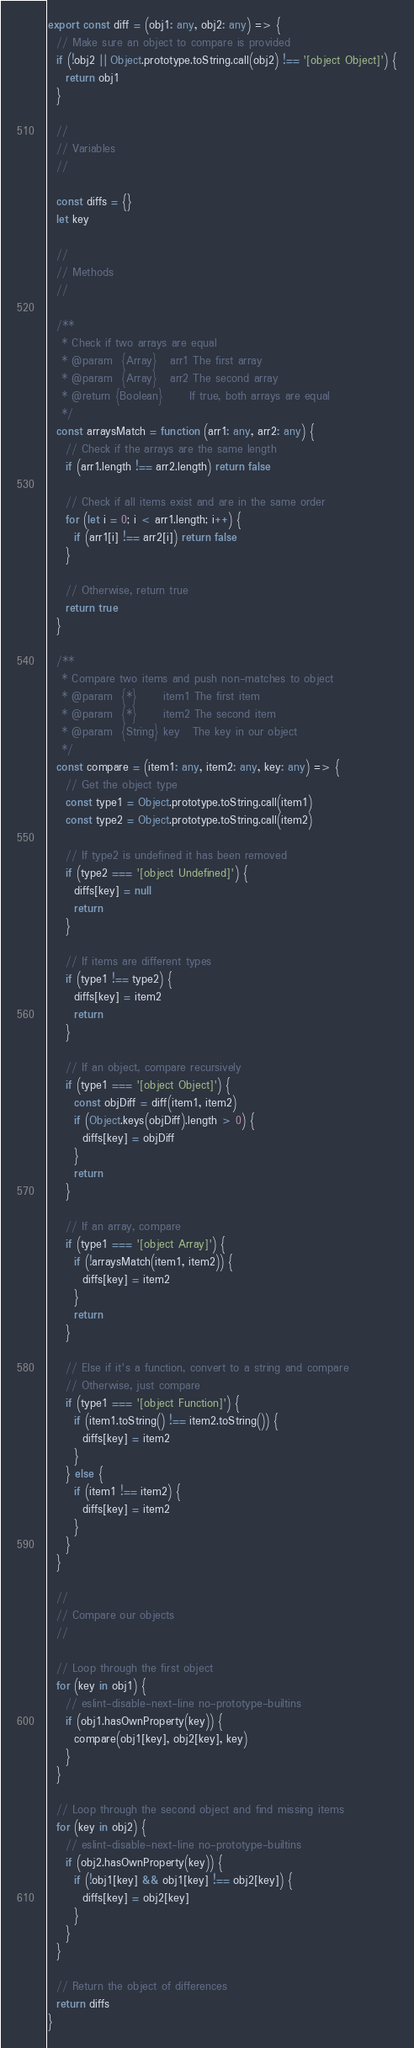<code> <loc_0><loc_0><loc_500><loc_500><_TypeScript_>export const diff = (obj1: any, obj2: any) => {
  // Make sure an object to compare is provided
  if (!obj2 || Object.prototype.toString.call(obj2) !== '[object Object]') {
    return obj1
  }

  //
  // Variables
  //

  const diffs = {}
  let key

  //
  // Methods
  //

  /**
   * Check if two arrays are equal
   * @param  {Array}   arr1 The first array
   * @param  {Array}   arr2 The second array
   * @return {Boolean}      If true, both arrays are equal
   */
  const arraysMatch = function (arr1: any, arr2: any) {
    // Check if the arrays are the same length
    if (arr1.length !== arr2.length) return false

    // Check if all items exist and are in the same order
    for (let i = 0; i < arr1.length; i++) {
      if (arr1[i] !== arr2[i]) return false
    }

    // Otherwise, return true
    return true
  }

  /**
   * Compare two items and push non-matches to object
   * @param  {*}      item1 The first item
   * @param  {*}      item2 The second item
   * @param  {String} key   The key in our object
   */
  const compare = (item1: any, item2: any, key: any) => {
    // Get the object type
    const type1 = Object.prototype.toString.call(item1)
    const type2 = Object.prototype.toString.call(item2)

    // If type2 is undefined it has been removed
    if (type2 === '[object Undefined]') {
      diffs[key] = null
      return
    }

    // If items are different types
    if (type1 !== type2) {
      diffs[key] = item2
      return
    }

    // If an object, compare recursively
    if (type1 === '[object Object]') {
      const objDiff = diff(item1, item2)
      if (Object.keys(objDiff).length > 0) {
        diffs[key] = objDiff
      }
      return
    }

    // If an array, compare
    if (type1 === '[object Array]') {
      if (!arraysMatch(item1, item2)) {
        diffs[key] = item2
      }
      return
    }

    // Else if it's a function, convert to a string and compare
    // Otherwise, just compare
    if (type1 === '[object Function]') {
      if (item1.toString() !== item2.toString()) {
        diffs[key] = item2
      }
    } else {
      if (item1 !== item2) {
        diffs[key] = item2
      }
    }
  }

  //
  // Compare our objects
  //

  // Loop through the first object
  for (key in obj1) {
    // eslint-disable-next-line no-prototype-builtins
    if (obj1.hasOwnProperty(key)) {
      compare(obj1[key], obj2[key], key)
    }
  }

  // Loop through the second object and find missing items
  for (key in obj2) {
    // eslint-disable-next-line no-prototype-builtins
    if (obj2.hasOwnProperty(key)) {
      if (!obj1[key] && obj1[key] !== obj2[key]) {
        diffs[key] = obj2[key]
      }
    }
  }

  // Return the object of differences
  return diffs
}
</code> 